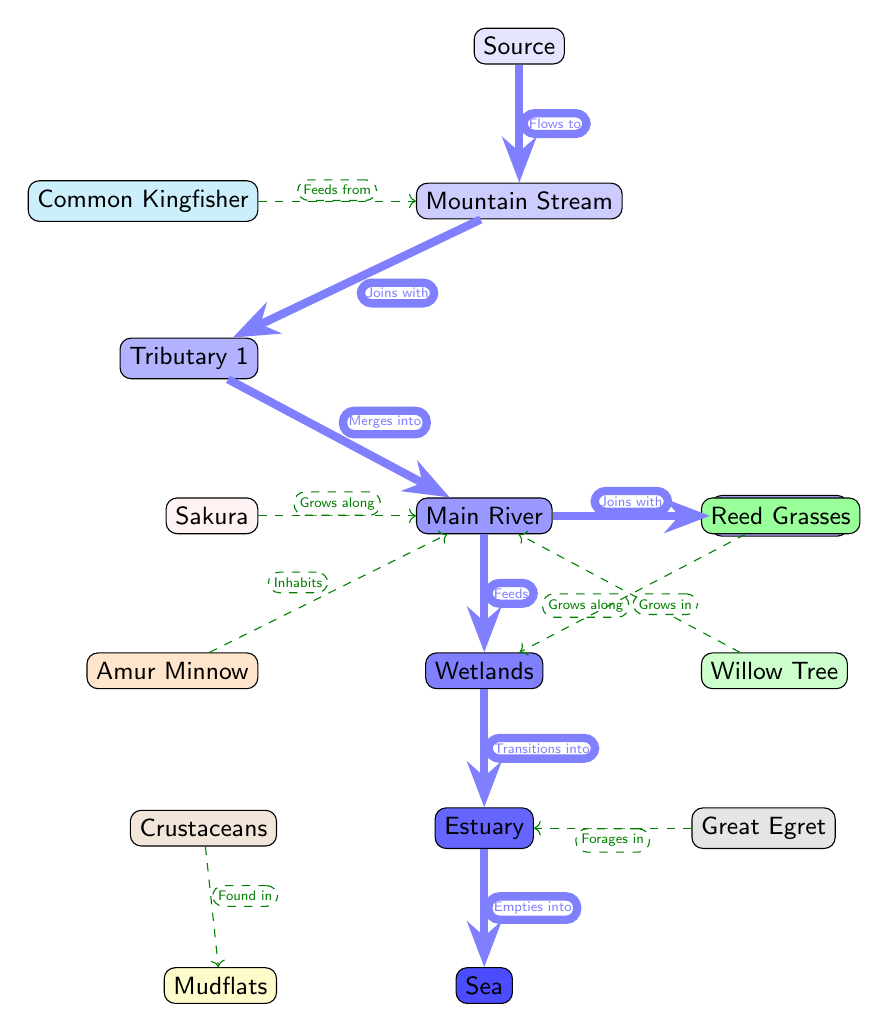What is the final destination of the river? The diagram shows the flow of the river leading to the last node labeled "Sea." The river flow progresses from the source through various stages before emptying into the sea.
Answer: Sea How many tributaries are depicted in the diagram? By examining the diagram, there are two tributaries that flow into the main river. One is labeled "Tributary 1" and the other "Tributary 2."
Answer: 2 What species is found in the wetlands? The diagram indicates that "Reed Grasses" grows in the wetlands, which is specifically connected to the wetlands node.
Answer: Reed Grasses Which organism feeds from the mountain stream? The connection labeled "Feeds from" indicates that the "Common Kingfisher" derives its food from the mountain stream as shown in the diagram.
Answer: Common Kingfisher What type of ecosystem transitions into the estuary? The diagram describes that "Wetlands" transition into the estuary, showing the connection between these two environmental types.
Answer: Wetlands How does the main river interact with the tributaries? The diagram illustrates that the main river "Joins with" Tributary 2 and "Merges into" the main river fed by Tributary 1. This indicates a merging of water flow.
Answer: Joins with, Merges into Which species inhabits the main river? The diagram specifies that the "Amur Minnow" inhabits the main river, clearly showing its association with this part of the ecosystem.
Answer: Amur Minnow What do the crustaceans specifically inhabit? According to the diagram, crustaceans are found prominently in the "Mudflats," highlighting their specific habitat within the ecosystem's geography.
Answer: Mudflats 